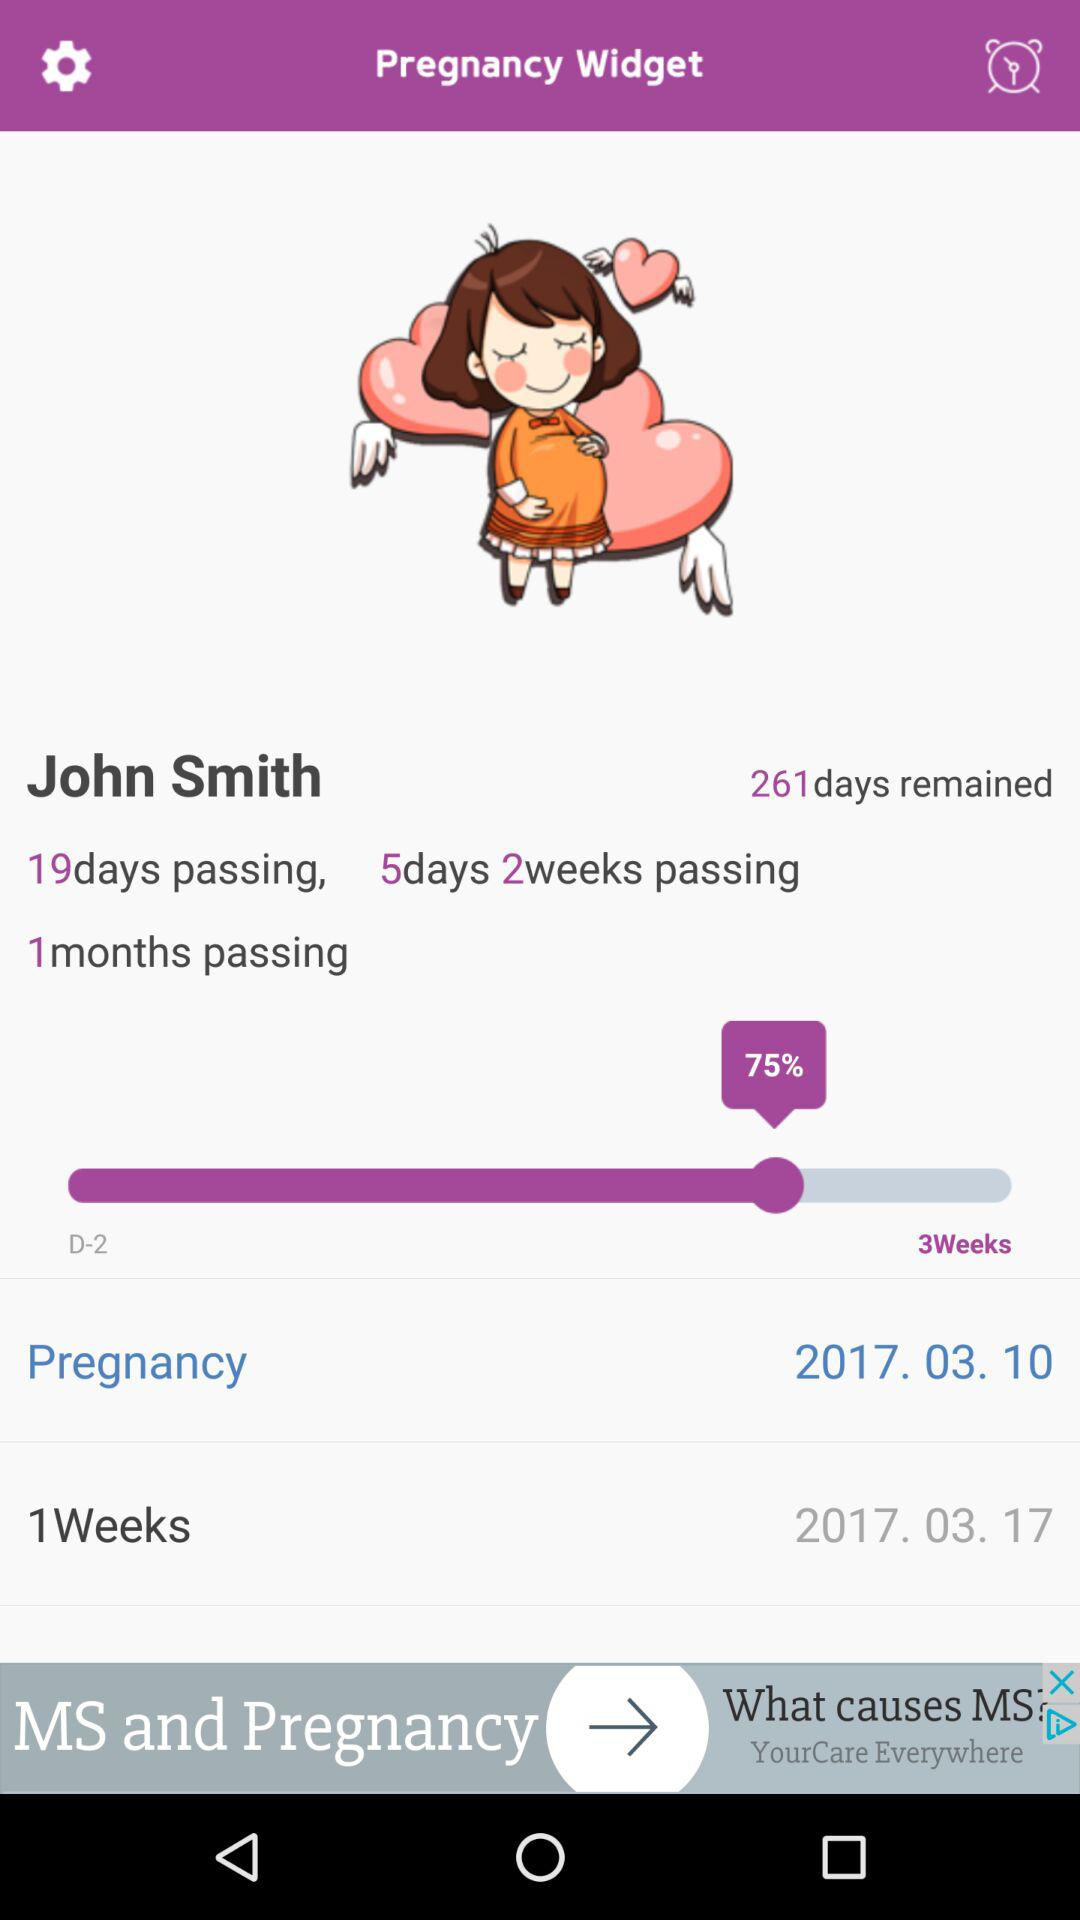What is the app name? The app name is "Pregnancy Widget". 